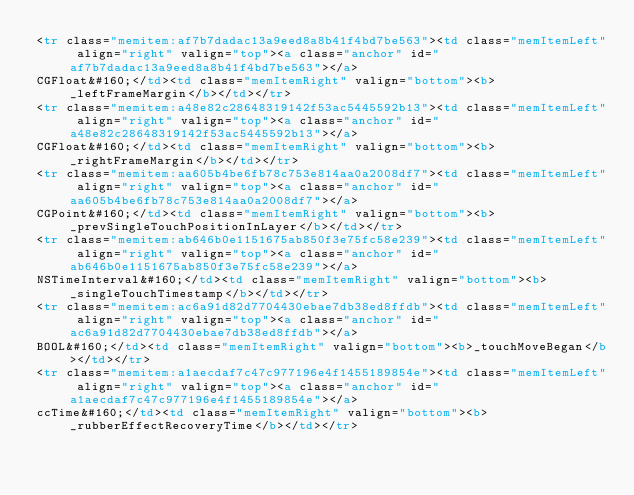Convert code to text. <code><loc_0><loc_0><loc_500><loc_500><_HTML_><tr class="memitem:af7b7dadac13a9eed8a8b41f4bd7be563"><td class="memItemLeft" align="right" valign="top"><a class="anchor" id="af7b7dadac13a9eed8a8b41f4bd7be563"></a>
CGFloat&#160;</td><td class="memItemRight" valign="bottom"><b>_leftFrameMargin</b></td></tr>
<tr class="memitem:a48e82c28648319142f53ac5445592b13"><td class="memItemLeft" align="right" valign="top"><a class="anchor" id="a48e82c28648319142f53ac5445592b13"></a>
CGFloat&#160;</td><td class="memItemRight" valign="bottom"><b>_rightFrameMargin</b></td></tr>
<tr class="memitem:aa605b4be6fb78c753e814aa0a2008df7"><td class="memItemLeft" align="right" valign="top"><a class="anchor" id="aa605b4be6fb78c753e814aa0a2008df7"></a>
CGPoint&#160;</td><td class="memItemRight" valign="bottom"><b>_prevSingleTouchPositionInLayer</b></td></tr>
<tr class="memitem:ab646b0e1151675ab850f3e75fc58e239"><td class="memItemLeft" align="right" valign="top"><a class="anchor" id="ab646b0e1151675ab850f3e75fc58e239"></a>
NSTimeInterval&#160;</td><td class="memItemRight" valign="bottom"><b>_singleTouchTimestamp</b></td></tr>
<tr class="memitem:ac6a91d82d7704430ebae7db38ed8ffdb"><td class="memItemLeft" align="right" valign="top"><a class="anchor" id="ac6a91d82d7704430ebae7db38ed8ffdb"></a>
BOOL&#160;</td><td class="memItemRight" valign="bottom"><b>_touchMoveBegan</b></td></tr>
<tr class="memitem:a1aecdaf7c47c977196e4f1455189854e"><td class="memItemLeft" align="right" valign="top"><a class="anchor" id="a1aecdaf7c47c977196e4f1455189854e"></a>
ccTime&#160;</td><td class="memItemRight" valign="bottom"><b>_rubberEffectRecoveryTime</b></td></tr></code> 